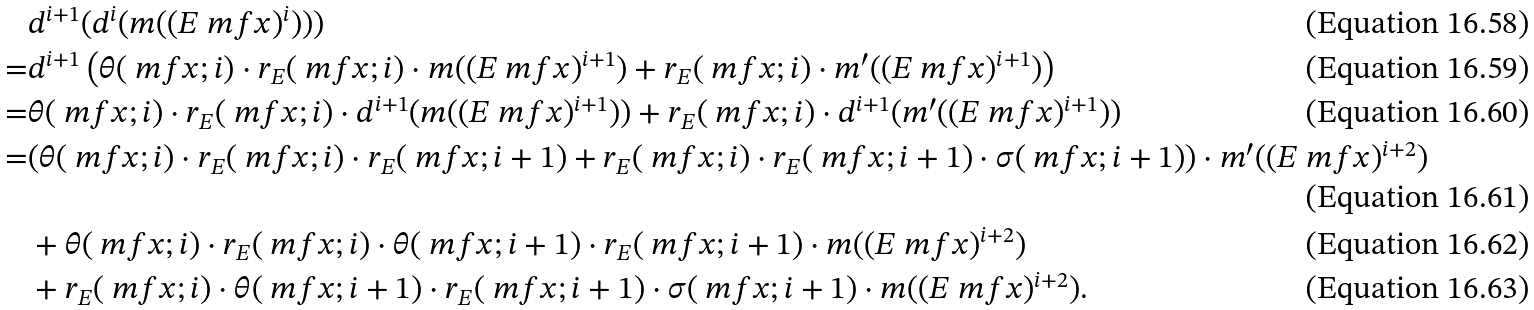Convert formula to latex. <formula><loc_0><loc_0><loc_500><loc_500>& d ^ { i + 1 } ( d ^ { i } ( m ( ( E \ m f { x } ) ^ { i } ) ) ) \\ = & d ^ { i + 1 } \left ( \theta ( \ m f { x } ; i ) \cdot r _ { E } ( \ m f { x } ; i ) \cdot m ( ( E \ m f { x } ) ^ { i + 1 } ) + r _ { E } ( \ m f { x } ; i ) \cdot m ^ { \prime } ( ( E \ m f { x } ) ^ { i + 1 } ) \right ) \\ = & \theta ( \ m f { x } ; i ) \cdot r _ { E } ( \ m f { x } ; i ) \cdot d ^ { i + 1 } ( m ( ( E \ m f { x } ) ^ { i + 1 } ) ) + r _ { E } ( \ m f { x } ; i ) \cdot d ^ { i + 1 } ( m ^ { \prime } ( ( E \ m f { x } ) ^ { i + 1 } ) ) \\ = & ( \theta ( \ m f { x } ; i ) \cdot r _ { E } ( \ m f { x } ; i ) \cdot r _ { E } ( \ m f { x } ; i + 1 ) + r _ { E } ( \ m f { x } ; i ) \cdot r _ { E } ( \ m f { x } ; i + 1 ) \cdot \sigma ( \ m f { x } ; i + 1 ) ) \cdot m ^ { \prime } ( ( E \ m f { x } ) ^ { i + 2 } ) \\ & + \theta ( \ m f { x } ; i ) \cdot r _ { E } ( \ m f { x } ; i ) \cdot \theta ( \ m f { x } ; i + 1 ) \cdot r _ { E } ( \ m f { x } ; i + 1 ) \cdot m ( ( E \ m f { x } ) ^ { i + 2 } ) \\ & + r _ { E } ( \ m f { x } ; i ) \cdot \theta ( \ m f { x } ; i + 1 ) \cdot r _ { E } ( \ m f { x } ; i + 1 ) \cdot \sigma ( \ m f { x } ; i + 1 ) \cdot m ( ( E \ m f { x } ) ^ { i + 2 } ) .</formula> 